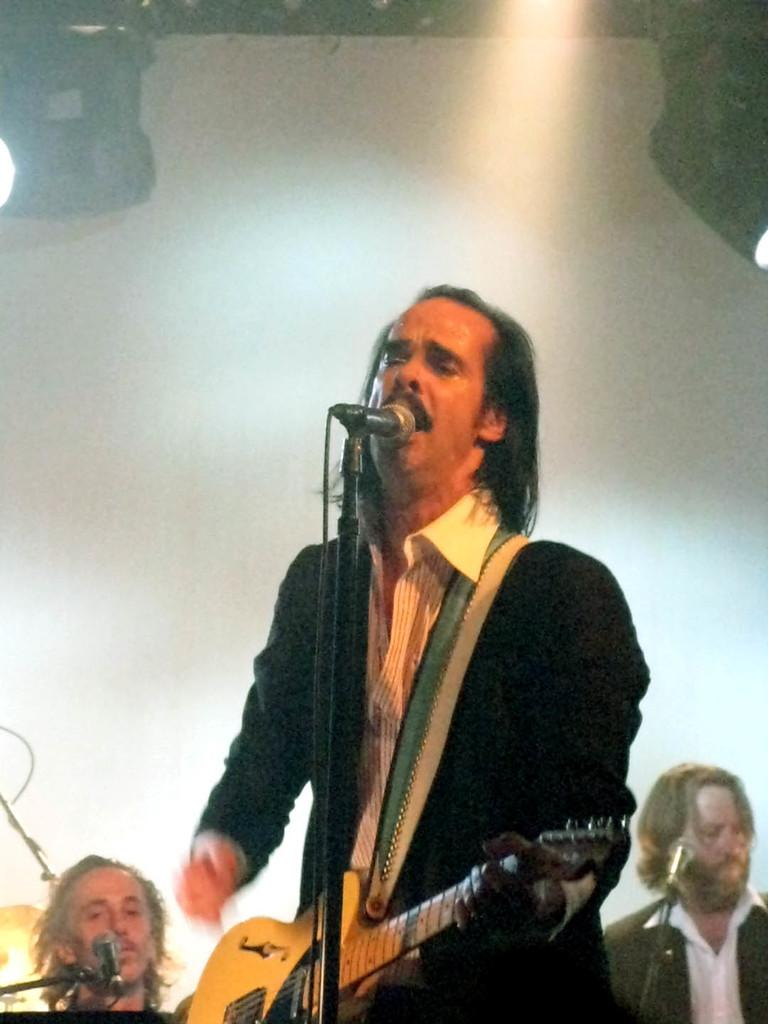What is the man wearing in the image? The man is wearing a black suit in the image. What is the man doing while wearing the black suit? The man is playing a guitar and singing in the image. What is in front of the man while he is playing the guitar and singing? There is a microphone in front of the man. Are there any other people present in the image? Yes, there are people in the background of the image. What is in front of the people in the background? There is a microphone in front of the people in the background. What can be seen at the top of the image? There are focusing lights visible at the top of the image. What type of steam is coming out of the guitar in the image? There is no steam coming out of the guitar in the image. What kind of treatment is the man receiving while playing the guitar and singing? There is no treatment being administered in the image; the man is simply playing the guitar and singing. 